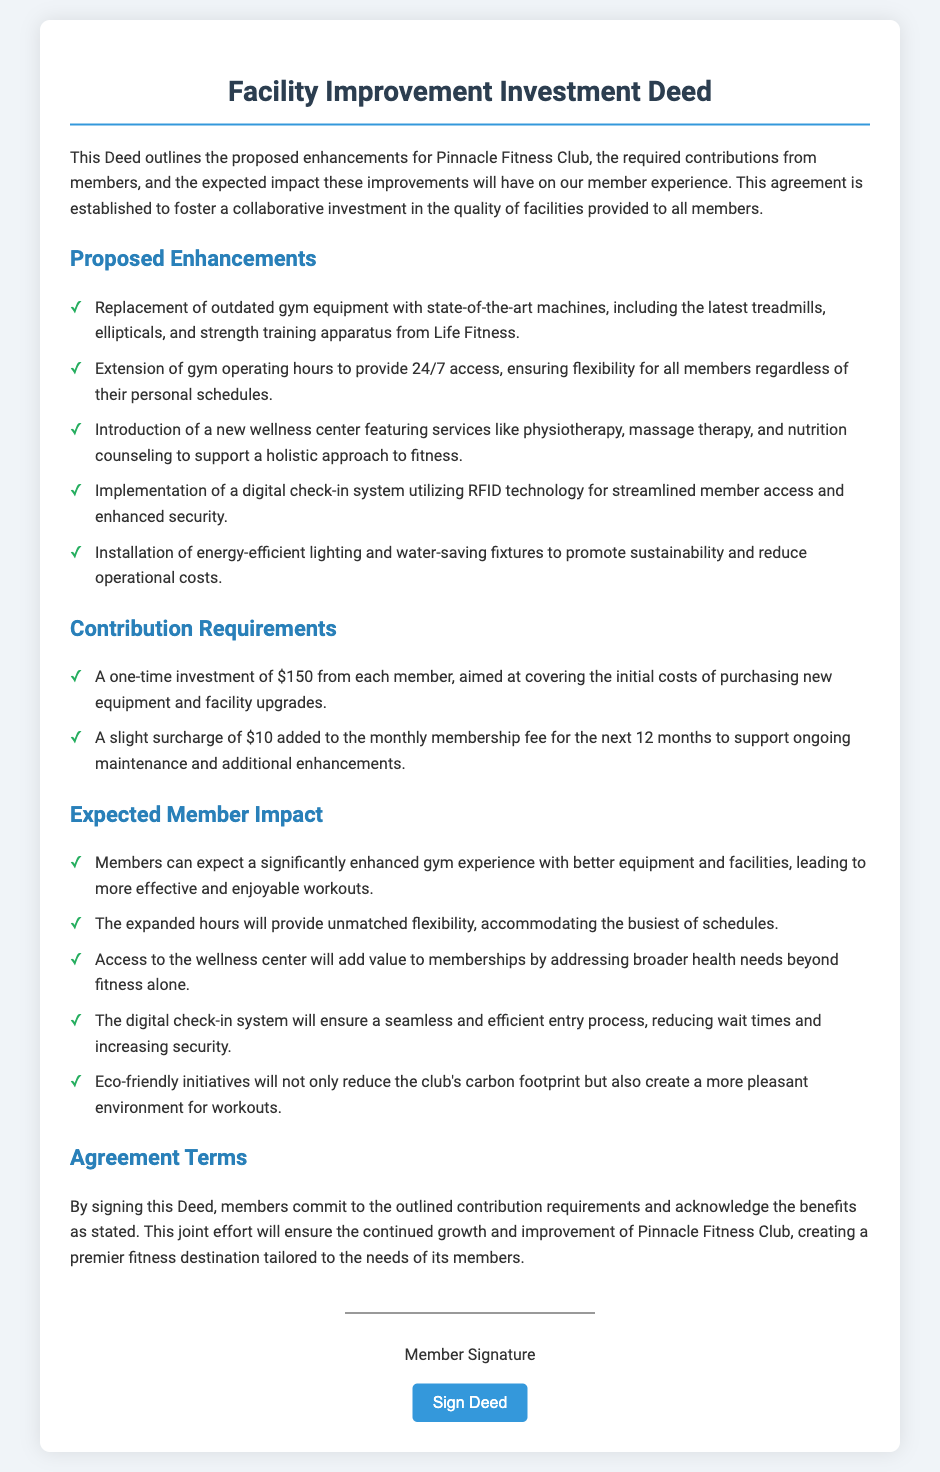What are the proposed enhancements? The proposed enhancements include the replacement of outdated gym equipment, extended gym operating hours, introduction of a wellness center, implementation of a digital check-in system, and installation of energy-efficient fixtures.
Answer: Replacement of outdated gym equipment, extended hours, wellness center, digital check-in system, energy-efficient fixtures What is the one-time investment amount? The one-time investment required from each member is mentioned in the contribution requirements section of the document.
Answer: $150 How long will the surcharge be applied? The duration for which the surcharge will be added to the monthly membership fee is specified in the contribution requirements.
Answer: 12 months What are the benefits of the digital check-in system? The benefits of the digital check-in system are explained under the expected member impact section of the document.
Answer: Seamless entry, reduced wait times, increased security What types of services will be available in the wellness center? The types of services included in the wellness center are listed in the proposed enhancements section.
Answer: Physiotherapy, massage therapy, nutrition counseling 